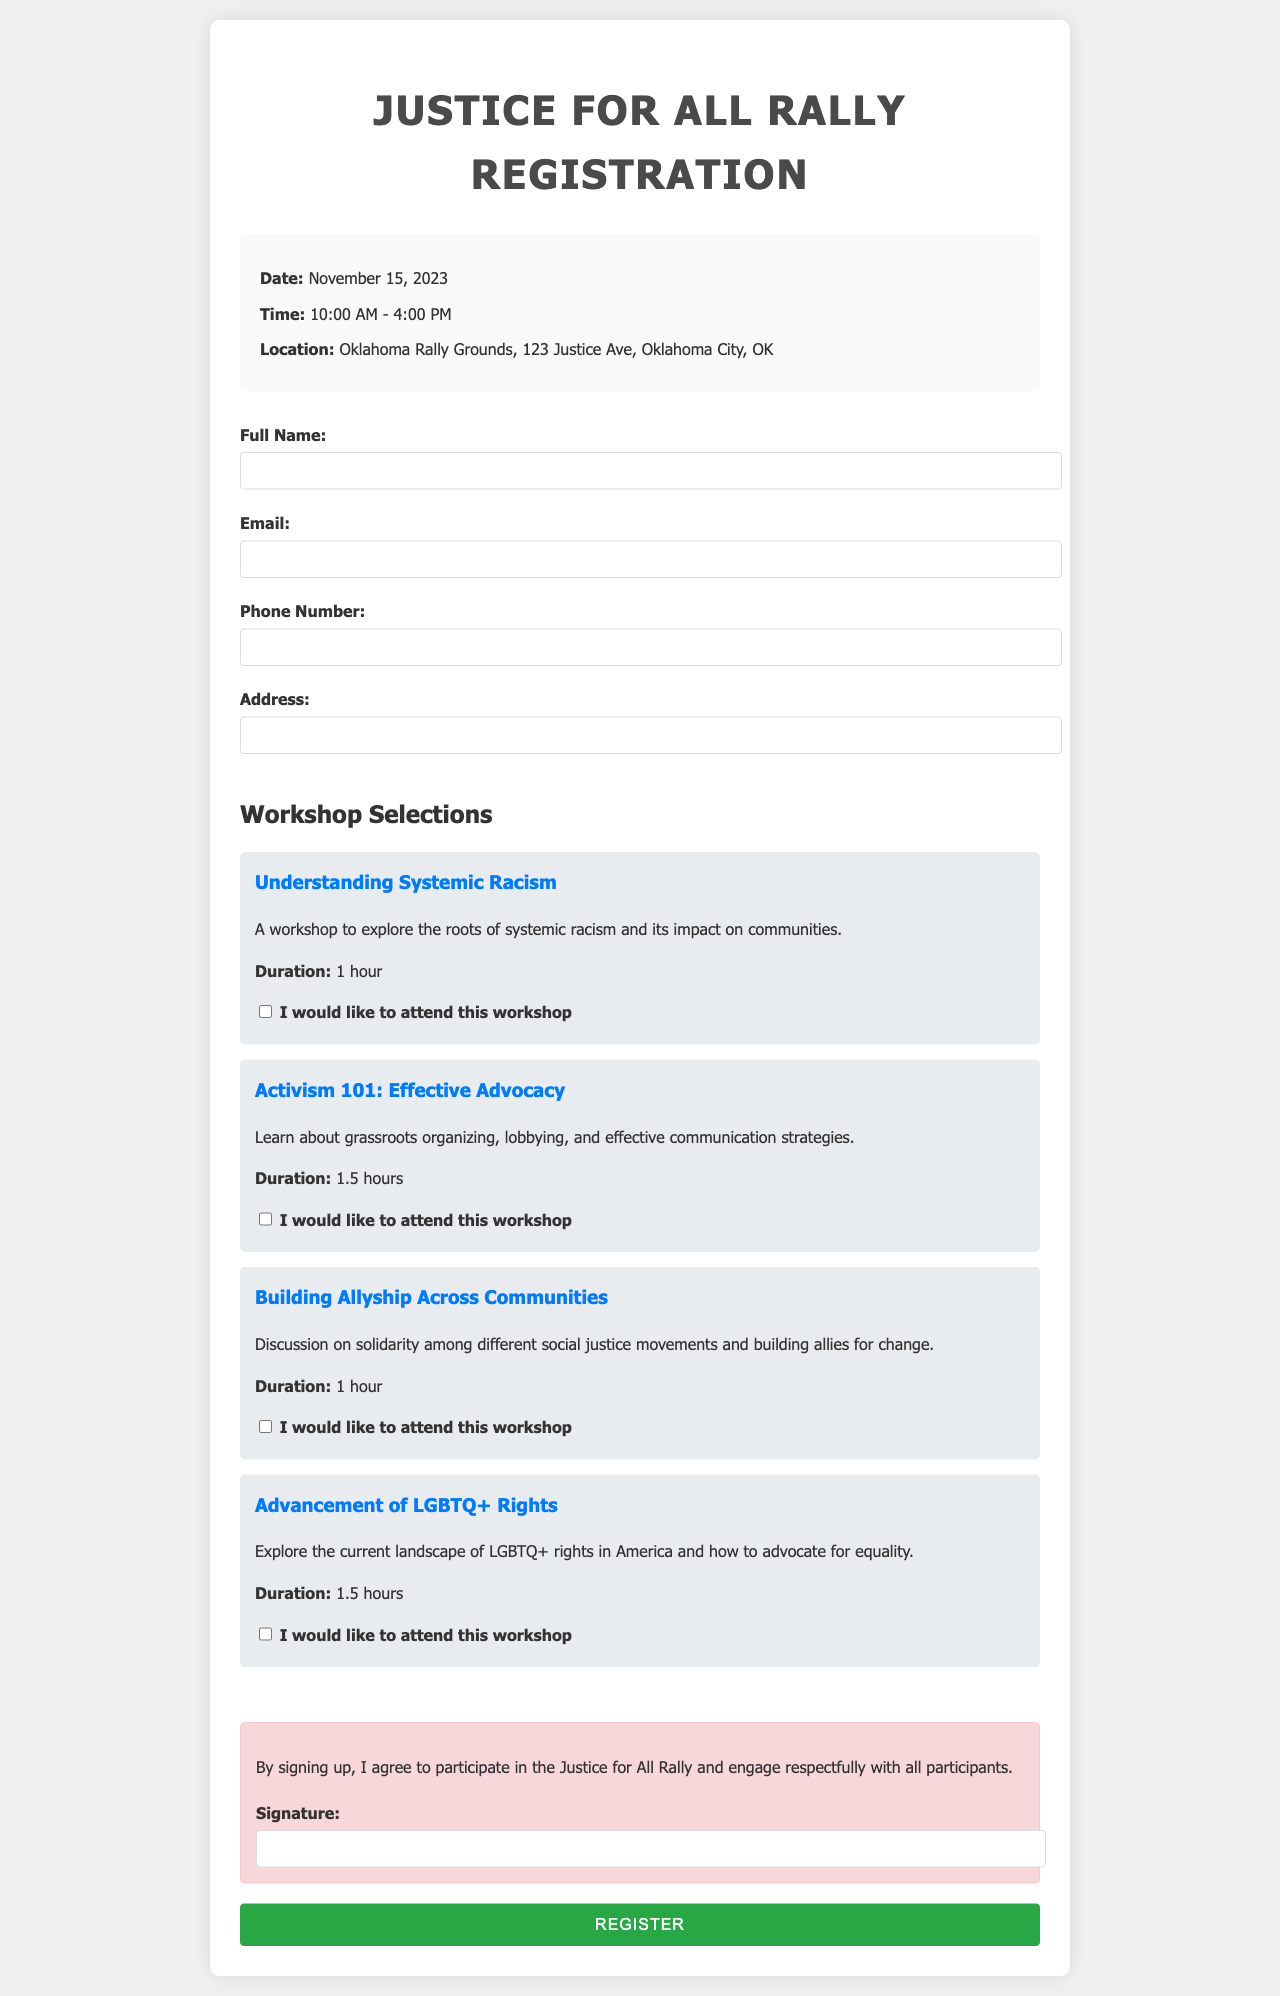what is the date of the event? The date is explicitly mentioned in the event details section.
Answer: November 15, 2023 what is the location of the rally? The location is specified in the event details.
Answer: Oklahoma Rally Grounds, 123 Justice Ave, Oklahoma City, OK how long does the "Activism 101: Effective Advocacy" workshop last? The duration of the workshop is listed in the description of the workshop.
Answer: 1.5 hours what is needed in order to register for the event? The requirements for registration are outlined in the form, particularly in the signature section.
Answer: Signature how many workshops are available for selection? The number of workshops can be tallied from the available options provided in the document.
Answer: 4 what is the time range for the event? The time range is indicated in the event details section.
Answer: 10:00 AM - 4:00 PM what is the purpose of the "Justice for All" rally? The purpose can be inferred from the title of the event and its context, signifying a call for social justice.
Answer: Social justice what are the types of contact information required for registration? The specific information requested is outlined in the participant section of the form.
Answer: Full Name, Email, Phone Number, Address 